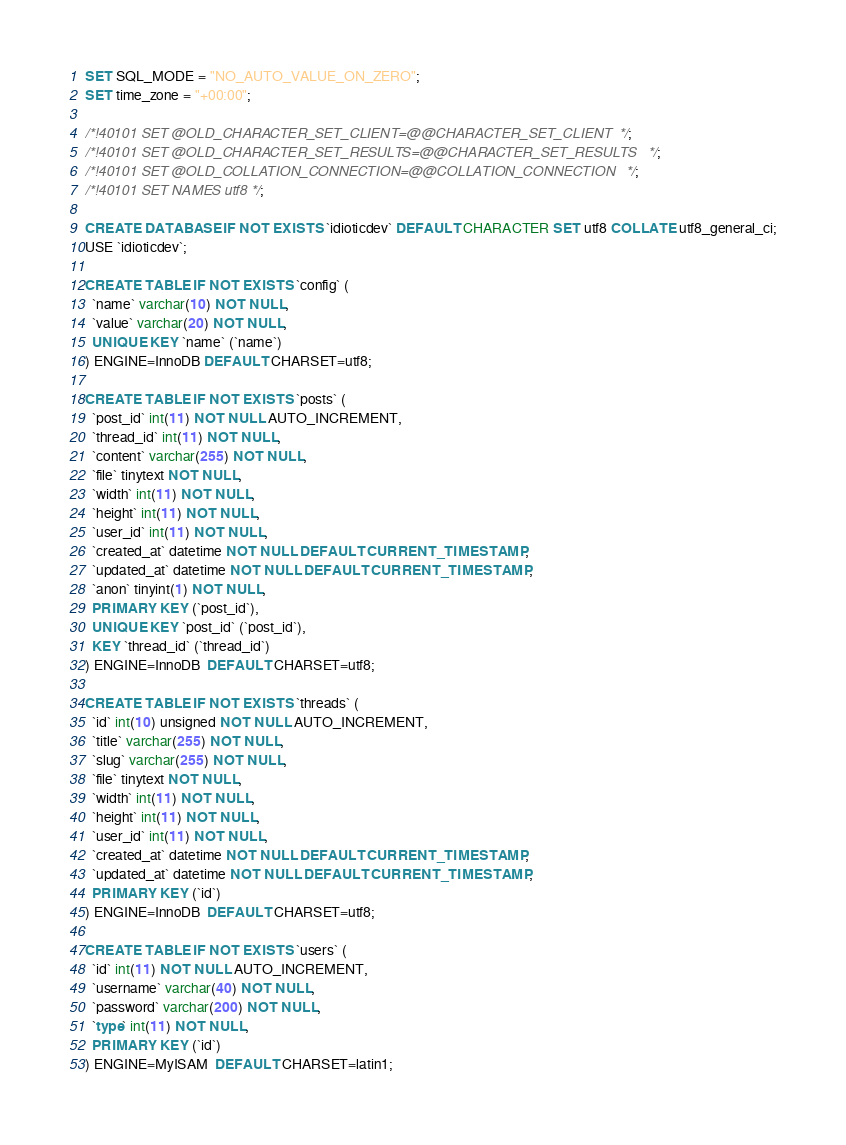Convert code to text. <code><loc_0><loc_0><loc_500><loc_500><_SQL_>SET SQL_MODE = "NO_AUTO_VALUE_ON_ZERO";
SET time_zone = "+00:00";

/*!40101 SET @OLD_CHARACTER_SET_CLIENT=@@CHARACTER_SET_CLIENT */;
/*!40101 SET @OLD_CHARACTER_SET_RESULTS=@@CHARACTER_SET_RESULTS */;
/*!40101 SET @OLD_COLLATION_CONNECTION=@@COLLATION_CONNECTION */;
/*!40101 SET NAMES utf8 */;

CREATE DATABASE IF NOT EXISTS `idioticdev` DEFAULT CHARACTER SET utf8 COLLATE utf8_general_ci;
USE `idioticdev`;

CREATE TABLE IF NOT EXISTS `config` (
  `name` varchar(10) NOT NULL,
  `value` varchar(20) NOT NULL,
  UNIQUE KEY `name` (`name`)
) ENGINE=InnoDB DEFAULT CHARSET=utf8;

CREATE TABLE IF NOT EXISTS `posts` (
  `post_id` int(11) NOT NULL AUTO_INCREMENT,
  `thread_id` int(11) NOT NULL,
  `content` varchar(255) NOT NULL,
  `file` tinytext NOT NULL,
  `width` int(11) NOT NULL,
  `height` int(11) NOT NULL,
  `user_id` int(11) NOT NULL,
  `created_at` datetime NOT NULL DEFAULT CURRENT_TIMESTAMP,
  `updated_at` datetime NOT NULL DEFAULT CURRENT_TIMESTAMP,
  `anon` tinyint(1) NOT NULL,
  PRIMARY KEY (`post_id`),
  UNIQUE KEY `post_id` (`post_id`),
  KEY `thread_id` (`thread_id`)
) ENGINE=InnoDB  DEFAULT CHARSET=utf8;

CREATE TABLE IF NOT EXISTS `threads` (
  `id` int(10) unsigned NOT NULL AUTO_INCREMENT,
  `title` varchar(255) NOT NULL,
  `slug` varchar(255) NOT NULL,
  `file` tinytext NOT NULL,
  `width` int(11) NOT NULL,
  `height` int(11) NOT NULL,
  `user_id` int(11) NOT NULL,
  `created_at` datetime NOT NULL DEFAULT CURRENT_TIMESTAMP,
  `updated_at` datetime NOT NULL DEFAULT CURRENT_TIMESTAMP,
  PRIMARY KEY (`id`)
) ENGINE=InnoDB  DEFAULT CHARSET=utf8;

CREATE TABLE IF NOT EXISTS `users` (
  `id` int(11) NOT NULL AUTO_INCREMENT,
  `username` varchar(40) NOT NULL,
  `password` varchar(200) NOT NULL,
  `type` int(11) NOT NULL,
  PRIMARY KEY (`id`)
) ENGINE=MyISAM  DEFAULT CHARSET=latin1;
</code> 